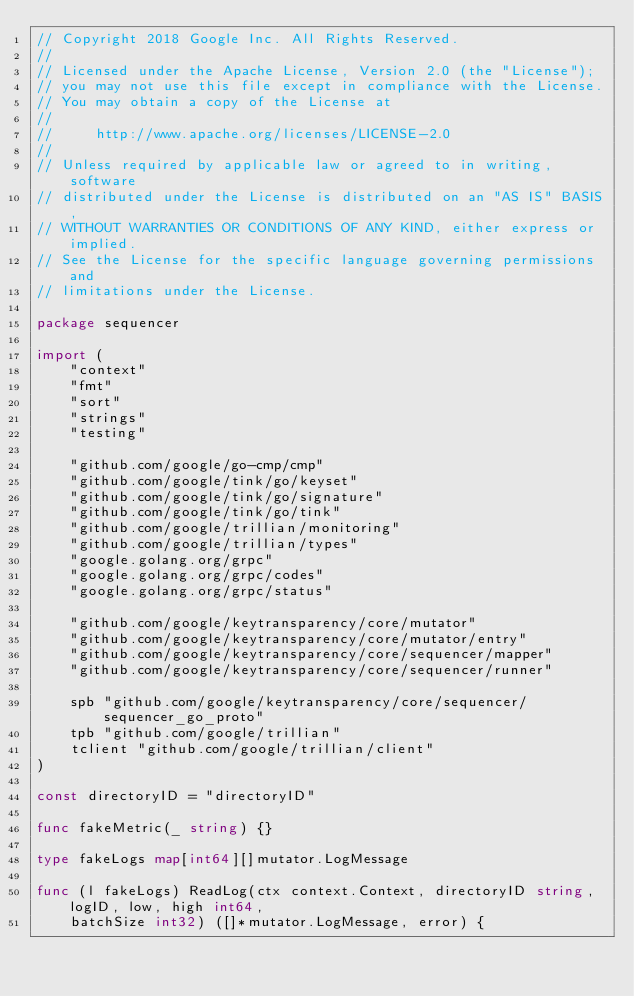<code> <loc_0><loc_0><loc_500><loc_500><_Go_>// Copyright 2018 Google Inc. All Rights Reserved.
//
// Licensed under the Apache License, Version 2.0 (the "License");
// you may not use this file except in compliance with the License.
// You may obtain a copy of the License at
//
//     http://www.apache.org/licenses/LICENSE-2.0
//
// Unless required by applicable law or agreed to in writing, software
// distributed under the License is distributed on an "AS IS" BASIS,
// WITHOUT WARRANTIES OR CONDITIONS OF ANY KIND, either express or implied.
// See the License for the specific language governing permissions and
// limitations under the License.

package sequencer

import (
	"context"
	"fmt"
	"sort"
	"strings"
	"testing"

	"github.com/google/go-cmp/cmp"
	"github.com/google/tink/go/keyset"
	"github.com/google/tink/go/signature"
	"github.com/google/tink/go/tink"
	"github.com/google/trillian/monitoring"
	"github.com/google/trillian/types"
	"google.golang.org/grpc"
	"google.golang.org/grpc/codes"
	"google.golang.org/grpc/status"

	"github.com/google/keytransparency/core/mutator"
	"github.com/google/keytransparency/core/mutator/entry"
	"github.com/google/keytransparency/core/sequencer/mapper"
	"github.com/google/keytransparency/core/sequencer/runner"

	spb "github.com/google/keytransparency/core/sequencer/sequencer_go_proto"
	tpb "github.com/google/trillian"
	tclient "github.com/google/trillian/client"
)

const directoryID = "directoryID"

func fakeMetric(_ string) {}

type fakeLogs map[int64][]mutator.LogMessage

func (l fakeLogs) ReadLog(ctx context.Context, directoryID string, logID, low, high int64,
	batchSize int32) ([]*mutator.LogMessage, error) {</code> 